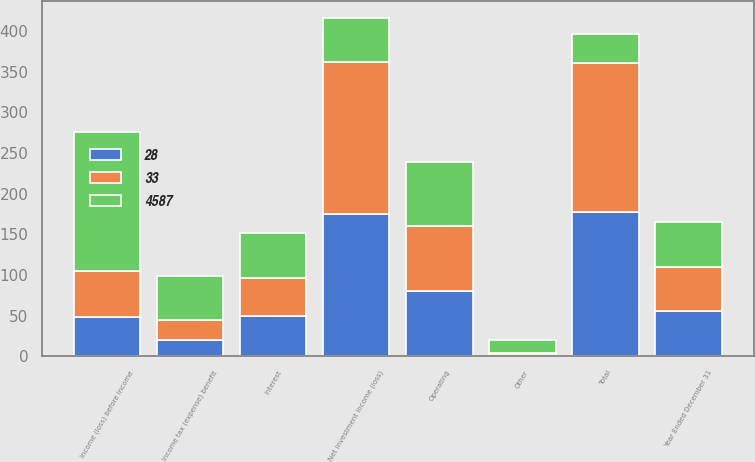Convert chart. <chart><loc_0><loc_0><loc_500><loc_500><stacked_bar_chart><ecel><fcel>Year Ended December 31<fcel>Net investment income (loss)<fcel>Other<fcel>Total<fcel>Operating<fcel>Interest<fcel>Income (loss) before income<fcel>Income tax (expense) benefit<nl><fcel>33<fcel>55<fcel>187<fcel>3<fcel>184<fcel>80<fcel>47<fcel>57<fcel>24<nl><fcel>28<fcel>55<fcel>175<fcel>1<fcel>177<fcel>80<fcel>49<fcel>48<fcel>20<nl><fcel>4587<fcel>55<fcel>54<fcel>16<fcel>36<fcel>79<fcel>56<fcel>171<fcel>55<nl></chart> 